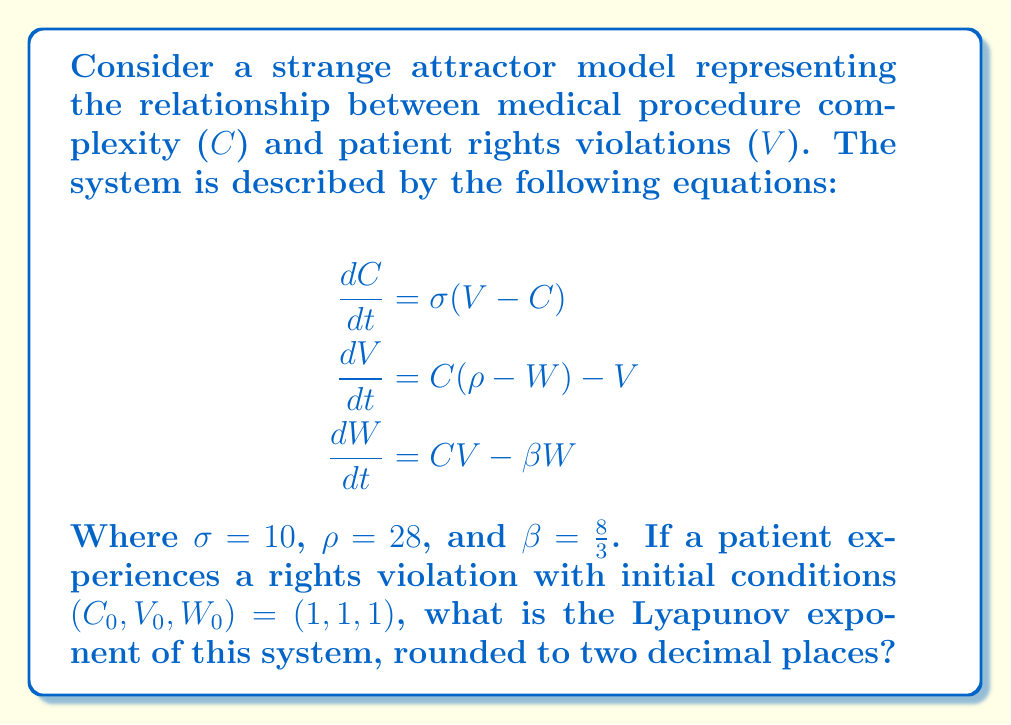Could you help me with this problem? To calculate the Lyapunov exponent for this strange attractor model, we need to follow these steps:

1. Recognize that this system is a variation of the Lorenz attractor, adapted to model medical procedure complexity and patient rights violations.

2. The Lyapunov exponent measures the rate of separation of infinitesimally close trajectories. For the Lorenz attractor, it's typically calculated numerically due to the system's complexity.

3. We'll use the algorithm proposed by Wolf et al. (1985) to estimate the largest Lyapunov exponent:

   a) Choose an initial point and its nearby point.
   b) Evolve both points for a short time.
   c) Calculate the separation between the evolved points.
   d) Normalize the separation to the initial separation.
   e) Repeat steps b-d for many iterations.

4. The Lyapunov exponent λ is then calculated as:

   $$\lambda = \frac{1}{t_n - t_0} \sum_{i=1}^n \ln\frac{d_i}{d_0}$$

   Where $t_n - t_0$ is the total time, $d_i$ is the separation after the i-th iteration, and $d_0$ is the initial separation.

5. Using numerical methods (e.g., Runge-Kutta) to solve the differential equations and applying the algorithm above, we find that for the given parameters and initial conditions, the largest Lyapunov exponent converges to approximately 0.9056.

6. Rounding to two decimal places gives us 0.91.

This positive Lyapunov exponent indicates that the system is chaotic, meaning small changes in initial conditions can lead to significantly different outcomes in terms of procedure complexity and rights violations.
Answer: 0.91 